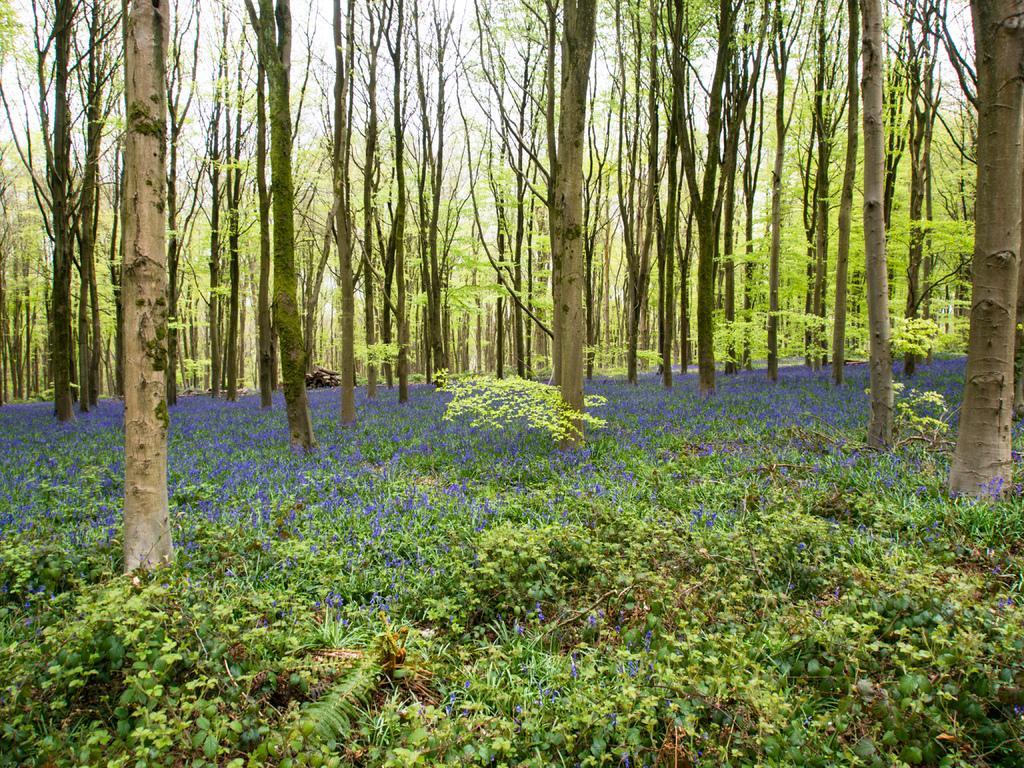In one or two sentences, can you explain what this image depicts? In this picture we can see plants with flowers and trees. Behind the trees there is a sky. 